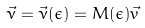Convert formula to latex. <formula><loc_0><loc_0><loc_500><loc_500>\vec { \nu } = \vec { \nu } ( \epsilon ) = M ( \epsilon ) \vec { v }</formula> 